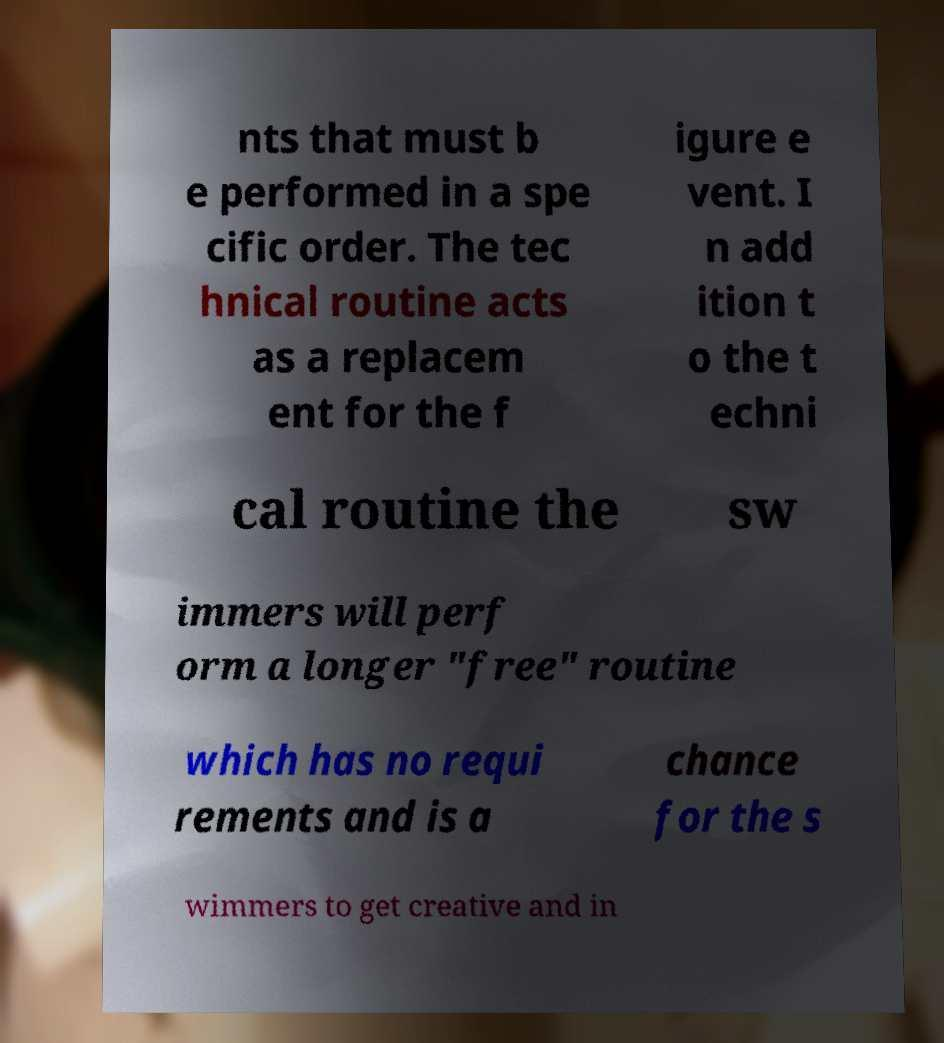Could you assist in decoding the text presented in this image and type it out clearly? nts that must b e performed in a spe cific order. The tec hnical routine acts as a replacem ent for the f igure e vent. I n add ition t o the t echni cal routine the sw immers will perf orm a longer "free" routine which has no requi rements and is a chance for the s wimmers to get creative and in 